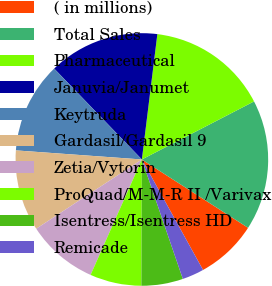Convert chart to OTSL. <chart><loc_0><loc_0><loc_500><loc_500><pie_chart><fcel>( in millions)<fcel>Total Sales<fcel>Pharmaceutical<fcel>Januvia/Janumet<fcel>Keytruda<fcel>Gardasil/Gardasil 9<fcel>Zetia/Vytorin<fcel>ProQuad/M-M-R II /Varivax<fcel>Isentress/Isentress HD<fcel>Remicade<nl><fcel>7.85%<fcel>16.7%<fcel>15.44%<fcel>14.17%<fcel>11.64%<fcel>10.38%<fcel>9.11%<fcel>6.59%<fcel>5.32%<fcel>2.79%<nl></chart> 